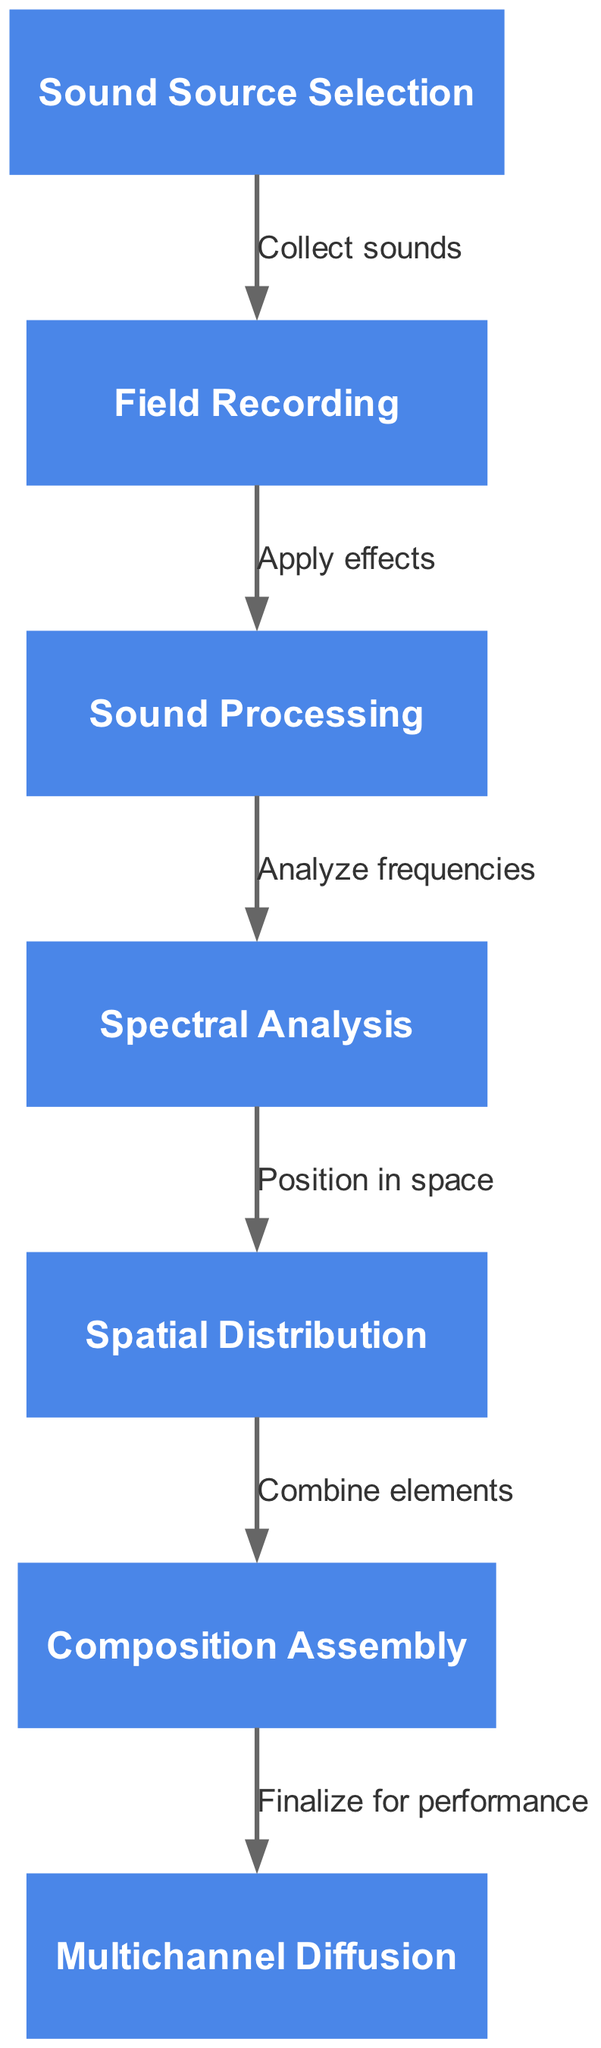What is the first step in the flowchart? The first step is indicated by the topmost node, which is "Sound Source Selection." This node represents the initial action in the compositional technique.
Answer: Sound Source Selection How many nodes are present in the diagram? By counting the nodes listed, we find there are 7 nodes in total within the flowchart.
Answer: 7 What action follows 'Field Recording'? The flow proceeds from 'Field Recording' to 'Sound Processing,' as shown by the directed edge connecting these two nodes.
Answer: Sound Processing What is the label on the edge from 'Sound Processing' to 'Spectral Analysis'? The edge connecting these two nodes shows the label "Analyze frequencies," indicating the action taken between these two steps.
Answer: Analyze frequencies What is the final step before 'Multichannel Diffusion'? The step preceding 'Multichannel Diffusion' is 'Composition Assembly,' as indicated by the directed edge leading into 'Multichannel Diffusion.' This shows the flow of the process.
Answer: Composition Assembly What does 'Spatial Distribution' lead to? 'Spatial Distribution' directly leads to 'Composition Assembly,' based on the directed edge that connects these two nodes.
Answer: Composition Assembly Which node involves applying effects to sound? The node labeled 'Sound Processing' specifies the action of applying effects to the sound collected, as it follows 'Field Recording.'
Answer: Sound Processing From which step do you collect sounds? Sounds are collected in the first step 'Sound Source Selection,' as shown by the initial node of the flowchart.
Answer: Sound Source Selection What connects 'Spectral Analysis' to 'Spatial Distribution'? The label on the edge connecting these two nodes is "Position in space," signifying the action taken after spectral analysis.
Answer: Position in space 